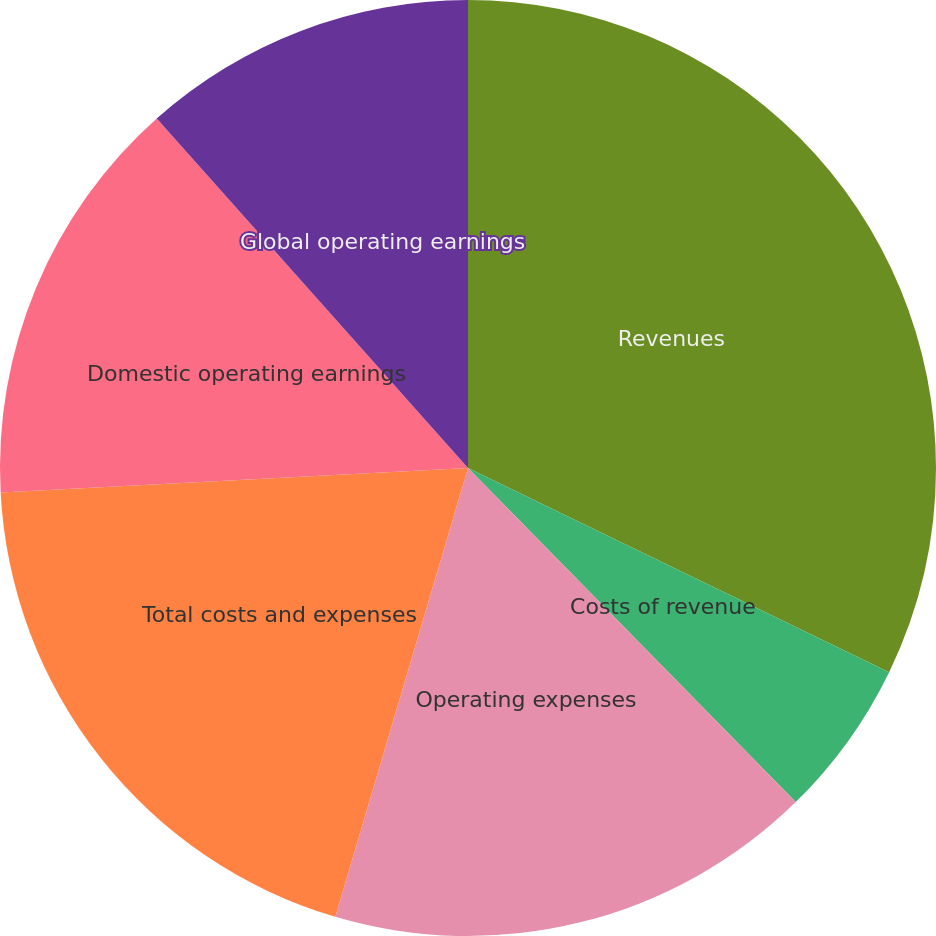Convert chart. <chart><loc_0><loc_0><loc_500><loc_500><pie_chart><fcel>Revenues<fcel>Costs of revenue<fcel>Operating expenses<fcel>Total costs and expenses<fcel>Domestic operating earnings<fcel>Global operating earnings<nl><fcel>32.18%<fcel>5.47%<fcel>16.92%<fcel>19.59%<fcel>14.25%<fcel>11.58%<nl></chart> 